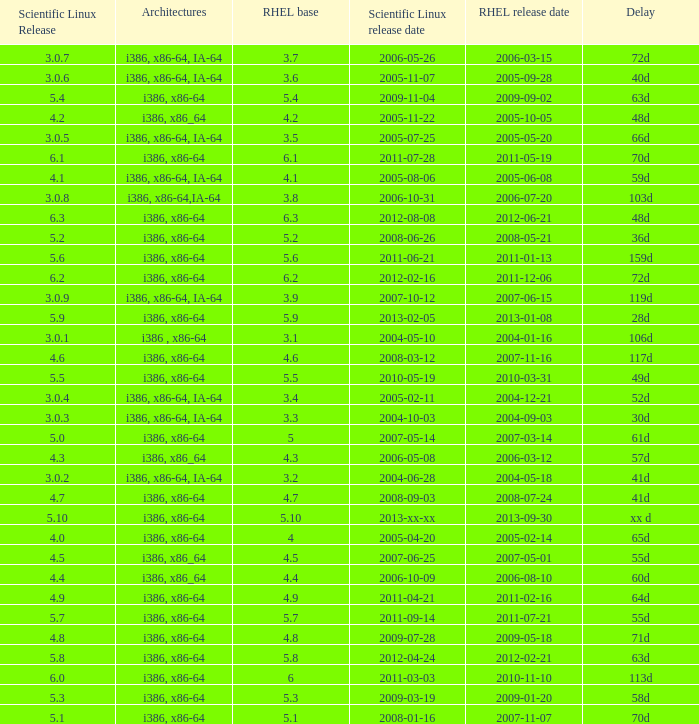When is the rhel release date when scientific linux release is 3.0.4 2004-12-21. 